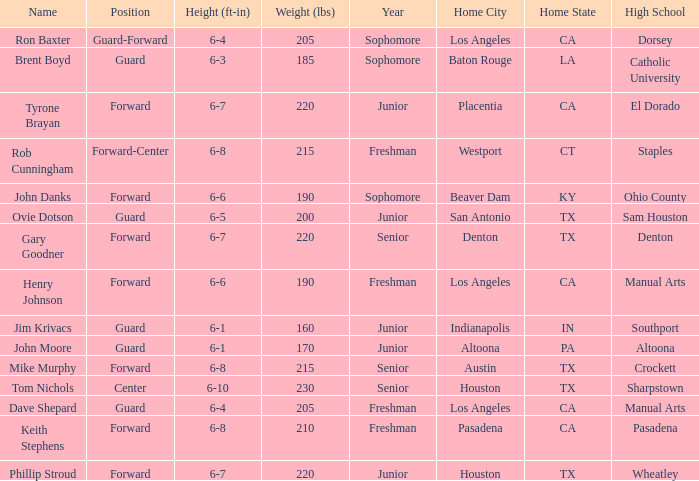What is the Name with a Year with freshman, and a Home Town with los angeles, ca, and a Height of 6–4? Dave Shepard. 